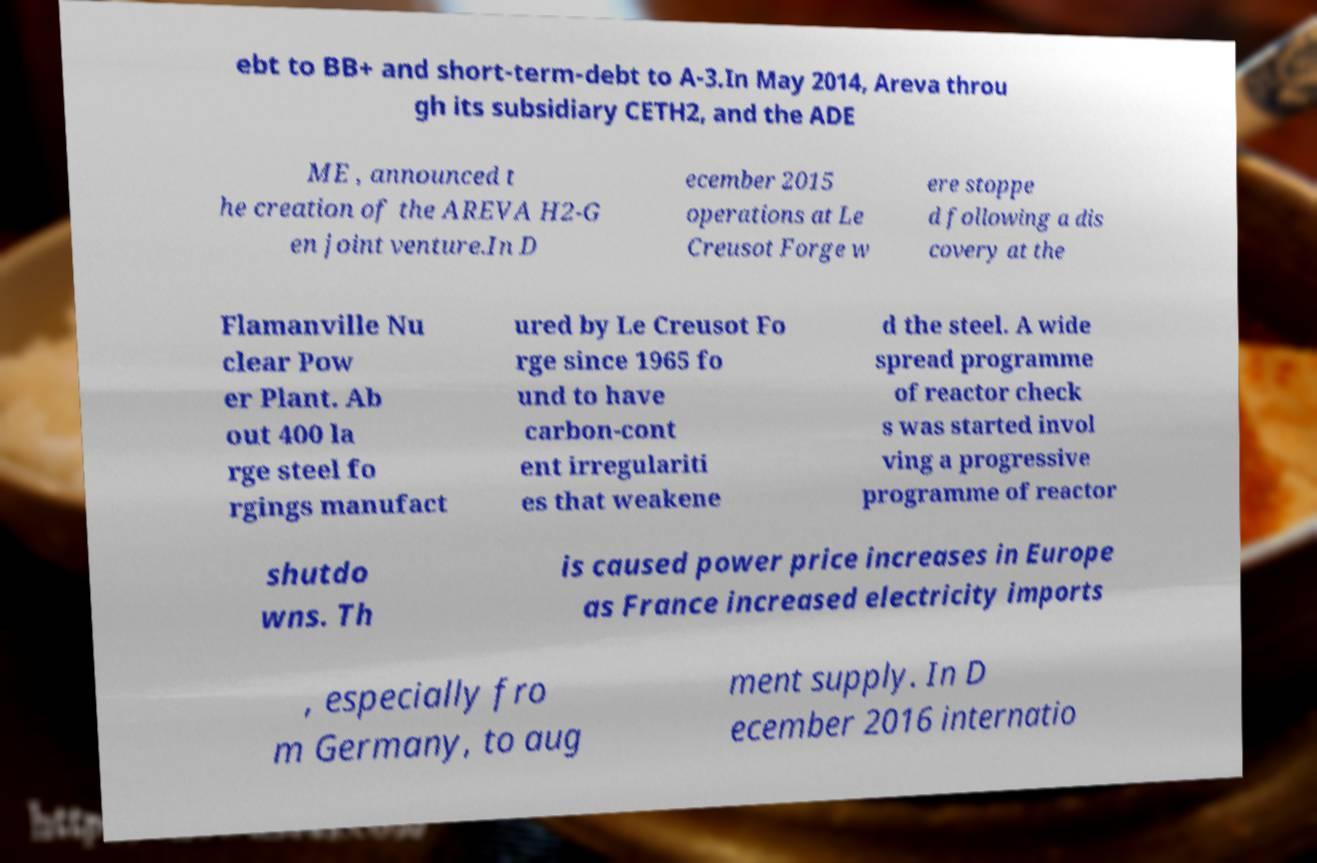Please identify and transcribe the text found in this image. ebt to BB+ and short-term-debt to A-3.In May 2014, Areva throu gh its subsidiary CETH2, and the ADE ME , announced t he creation of the AREVA H2-G en joint venture.In D ecember 2015 operations at Le Creusot Forge w ere stoppe d following a dis covery at the Flamanville Nu clear Pow er Plant. Ab out 400 la rge steel fo rgings manufact ured by Le Creusot Fo rge since 1965 fo und to have carbon-cont ent irregulariti es that weakene d the steel. A wide spread programme of reactor check s was started invol ving a progressive programme of reactor shutdo wns. Th is caused power price increases in Europe as France increased electricity imports , especially fro m Germany, to aug ment supply. In D ecember 2016 internatio 